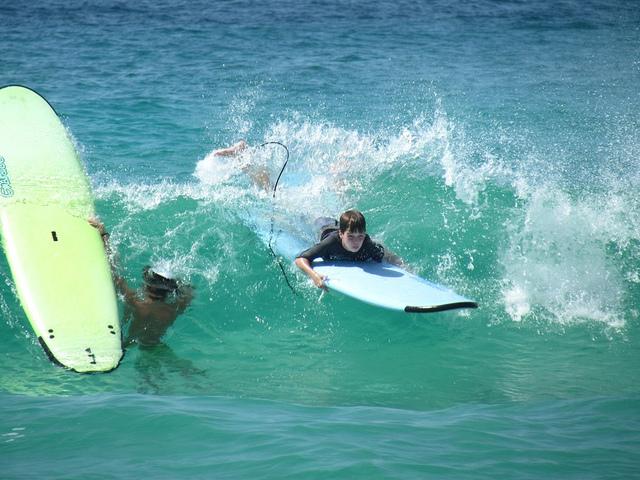What color is the water?
Concise answer only. Blue. What is the boy laying on?
Short answer required. Surfboard. What is the name on the surfboard?
Be succinct. Quicksilver. How to the boys not lose their boards?
Concise answer only. 1. 